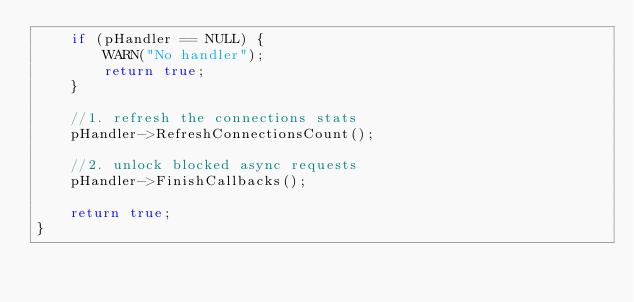Convert code to text. <code><loc_0><loc_0><loc_500><loc_500><_C++_>	if (pHandler == NULL) {
		WARN("No handler");
		return true;
	}

	//1. refresh the connections stats
	pHandler->RefreshConnectionsCount();

	//2. unlock blocked async requests
	pHandler->FinishCallbacks();

	return true;
}
</code> 